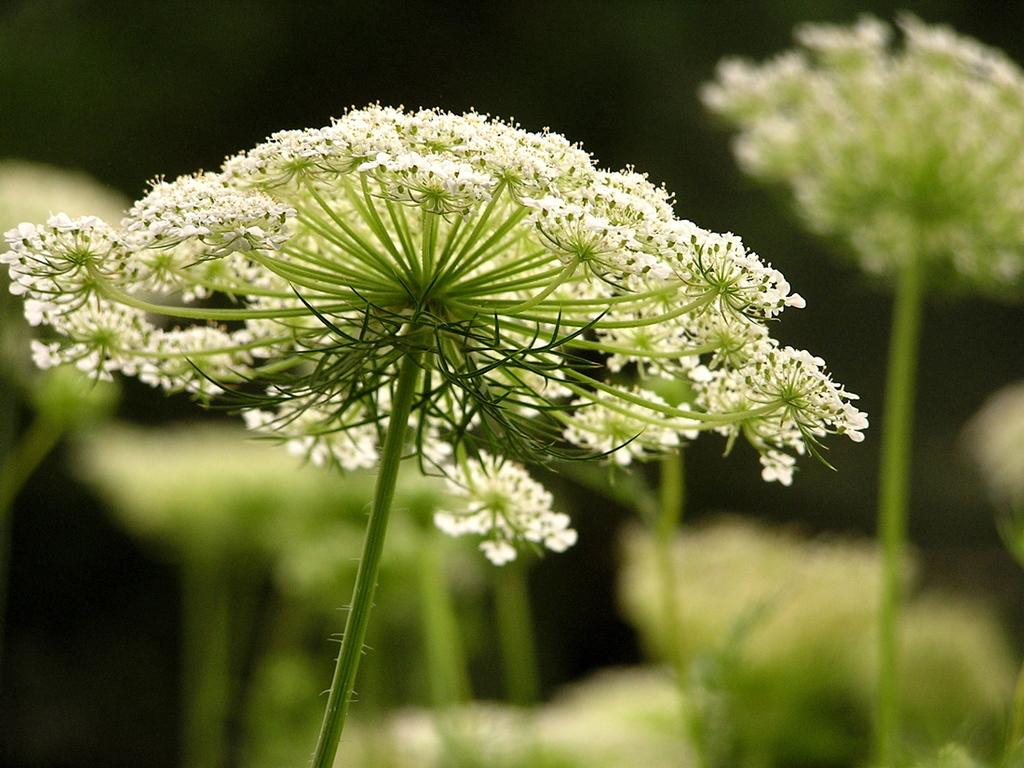What type of living organisms can be seen in the image? There are flowers in the image. Can you describe the background of the image? The background of the image is blurred. What type of cloth is being used to cover the kettle in the image? There is no kettle present in the image, so it is not possible to determine what type of cloth might be used to cover it. 